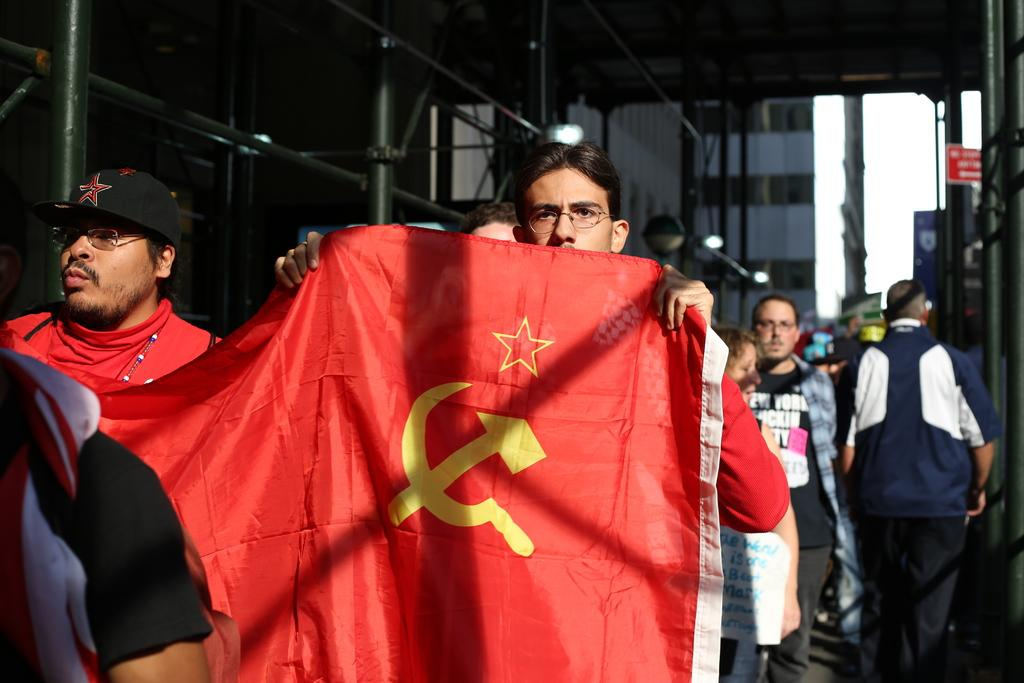What are the two people in the image holding? The two people in the image are holding a flag. Can you describe the other people visible in the image? There are other people visible in the image, but their specific actions or features are not mentioned in the provided facts. What type of structures can be seen in the image? There are buildings in the image. What type of apparatus is being used by the people to ring the bells in the image? There is no apparatus or bells present in the image; the two people are holding a flag. Can you describe the umbrella being used by the person in the image? There is no umbrella present in the image. 